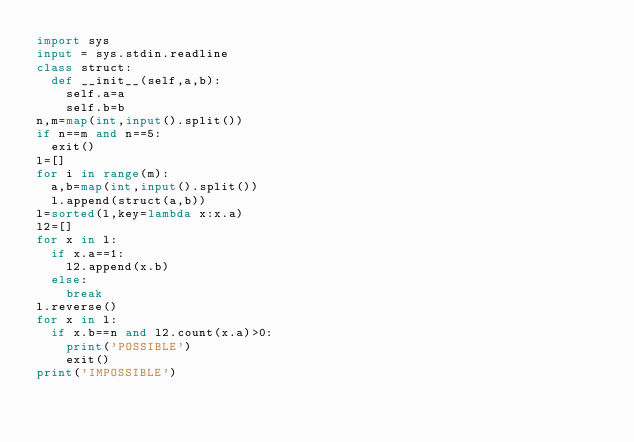Convert code to text. <code><loc_0><loc_0><loc_500><loc_500><_Python_>import sys
input = sys.stdin.readline
class struct:
  def __init__(self,a,b):
    self.a=a
    self.b=b
n,m=map(int,input().split())
if n==m and n==5:
  exit()
l=[]
for i in range(m):
  a,b=map(int,input().split())
  l.append(struct(a,b))
l=sorted(l,key=lambda x:x.a)
l2=[]
for x in l:
  if x.a==1:
    l2.append(x.b)
  else:
    break
l.reverse()
for x in l:
  if x.b==n and l2.count(x.a)>0:
    print('POSSIBLE')
    exit()
print('IMPOSSIBLE')</code> 